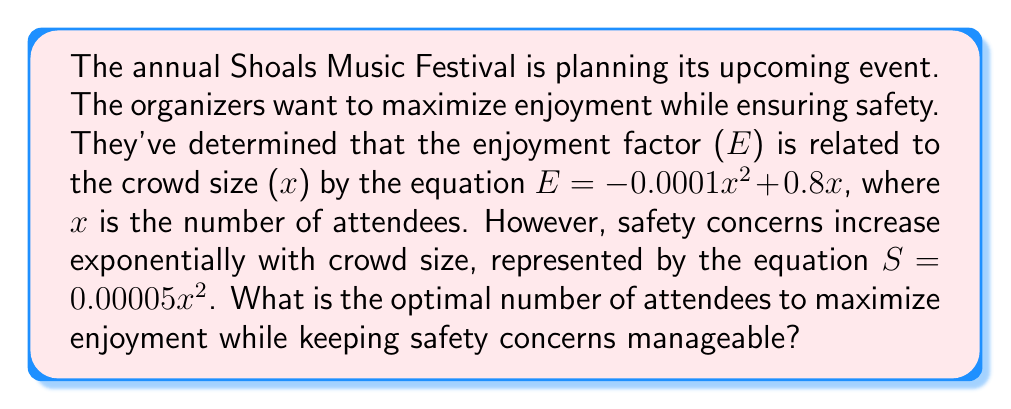Can you answer this question? To find the optimal crowd size, we need to maximize the difference between enjoyment (E) and safety concerns (S). Let's call this difference F(x):

1) $F(x) = E - S = (-0.0001x^2 + 0.8x) - (0.00005x^2)$

2) Simplify: $F(x) = -0.00015x^2 + 0.8x$

3) To find the maximum, we need to find where the derivative of F(x) equals zero:
   $F'(x) = -0.0003x + 0.8$

4) Set $F'(x) = 0$:
   $-0.0003x + 0.8 = 0$

5) Solve for x:
   $-0.0003x = -0.8$
   $x = \frac{-0.8}{-0.0003} = 2666.67$

6) Since we're dealing with people, we round down to the nearest whole number: 2666

7) To confirm this is a maximum (not a minimum), check the second derivative:
   $F''(x) = -0.0003$, which is negative, confirming a maximum.

Therefore, the optimal number of attendees is 2666.
Answer: 2666 attendees 